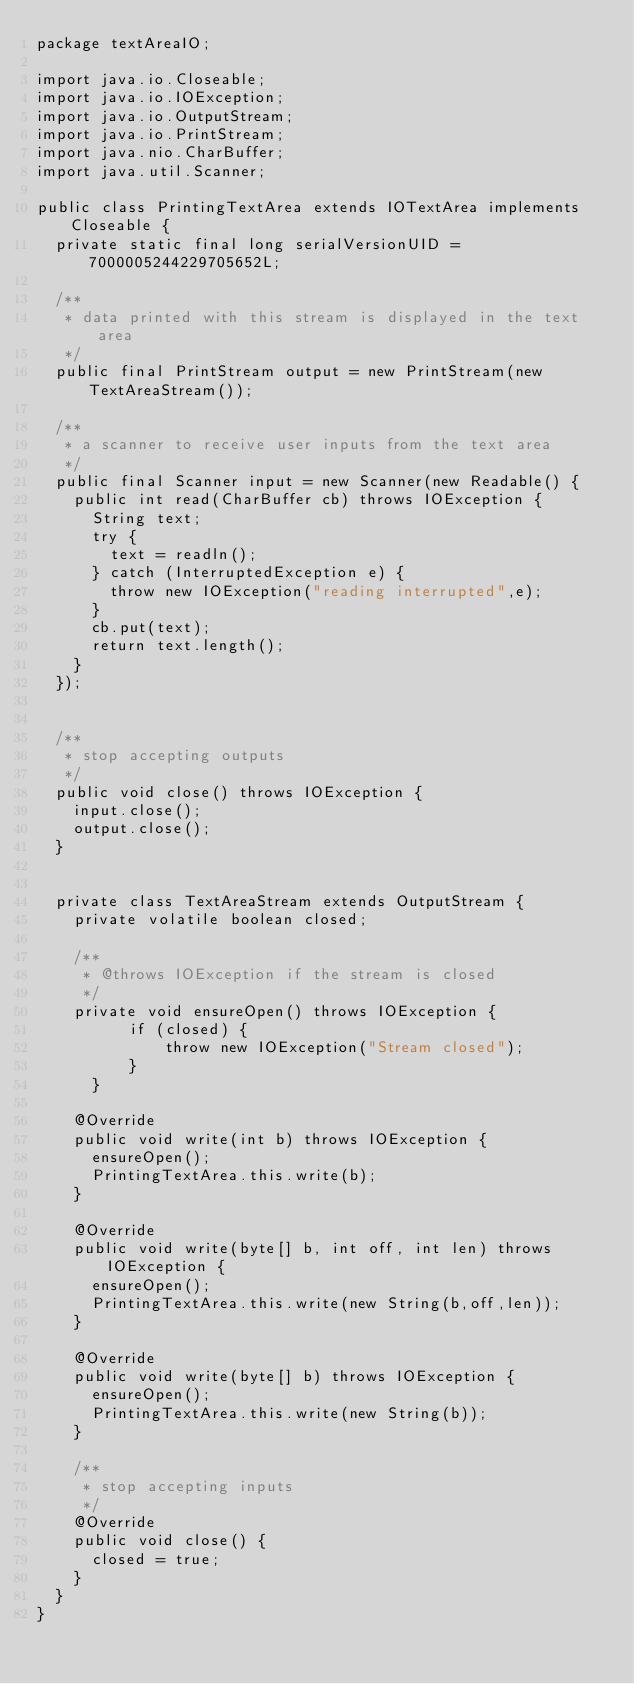<code> <loc_0><loc_0><loc_500><loc_500><_Java_>package textAreaIO;

import java.io.Closeable;
import java.io.IOException;
import java.io.OutputStream;
import java.io.PrintStream;
import java.nio.CharBuffer;
import java.util.Scanner;

public class PrintingTextArea extends IOTextArea implements Closeable {
	private static final long serialVersionUID = 7000005244229705652L;
	
	/**
	 * data printed with this stream is displayed in the text area
	 */
	public final PrintStream output = new PrintStream(new TextAreaStream());
	
	/**
	 * a scanner to receive user inputs from the text area
	 */
	public final Scanner input = new Scanner(new Readable() {
		public int read(CharBuffer cb) throws IOException {
			String text;
			try {
				text = readln();
			} catch (InterruptedException e) {
				throw new IOException("reading interrupted",e);
			}
			cb.put(text);
			return text.length();
		}
	});


	/**
	 * stop accepting outputs
	 */
	public void close() throws IOException {
		input.close();
		output.close();
	}


	private class TextAreaStream extends OutputStream {
		private volatile boolean closed;
	
		/**
		 * @throws IOException if the stream is closed
		 */
		private void ensureOpen() throws IOException {
	        if (closed) {
	            throw new IOException("Stream closed");
	        }
	    }
	
		@Override
		public void write(int b) throws IOException {
			ensureOpen();
			PrintingTextArea.this.write(b);
		}
		
		@Override
		public void write(byte[] b, int off, int len) throws IOException {
			ensureOpen();
			PrintingTextArea.this.write(new String(b,off,len));
		}
		
		@Override
		public void write(byte[] b) throws IOException {
			ensureOpen();
			PrintingTextArea.this.write(new String(b));
		}
		
		/**
		 * stop accepting inputs
		 */
		@Override
		public void close() {
			closed = true;
		}
	}
}
</code> 